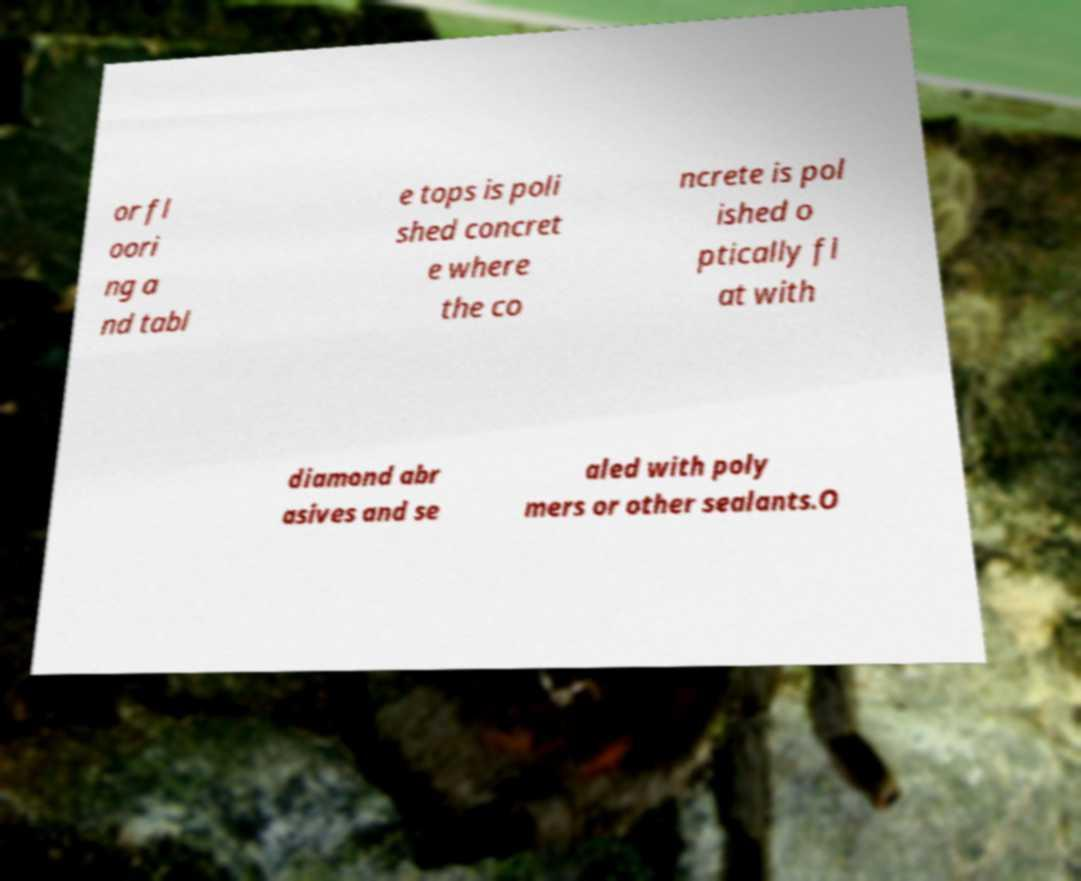Could you assist in decoding the text presented in this image and type it out clearly? or fl oori ng a nd tabl e tops is poli shed concret e where the co ncrete is pol ished o ptically fl at with diamond abr asives and se aled with poly mers or other sealants.O 